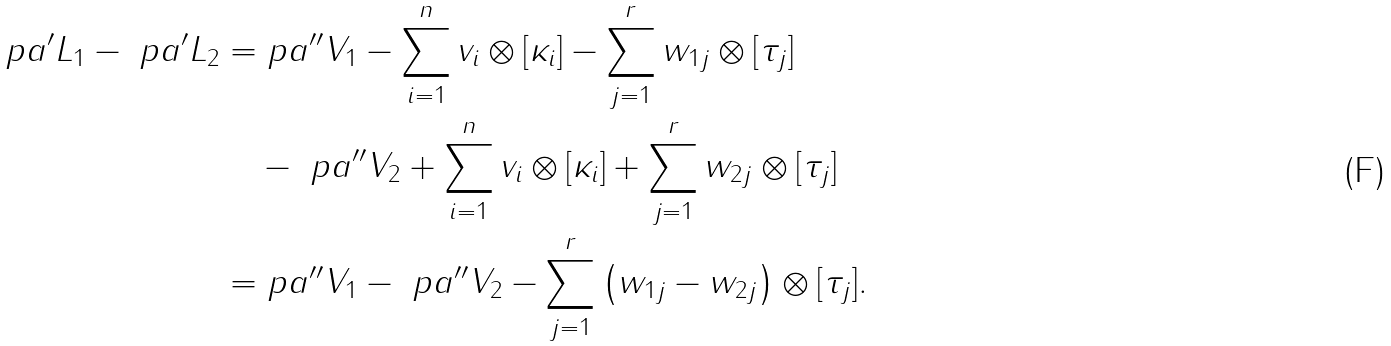<formula> <loc_0><loc_0><loc_500><loc_500>\ p a ^ { \prime } L _ { 1 } - \ p a ^ { \prime } L _ { 2 } = & \ p a ^ { \prime \prime } V _ { 1 } - \sum _ { i = 1 } ^ { n } v _ { i } \otimes [ \kappa _ { i } ] - \sum _ { j = 1 } ^ { r } w _ { 1 j } \otimes [ \tau _ { j } ] \\ & - \ p a ^ { \prime \prime } V _ { 2 } + \sum _ { i = 1 } ^ { n } v _ { i } \otimes [ \kappa _ { i } ] + \sum _ { j = 1 } ^ { r } w _ { 2 j } \otimes [ \tau _ { j } ] \\ = & \ p a ^ { \prime \prime } V _ { 1 } - \ p a ^ { \prime \prime } V _ { 2 } - \sum _ { j = 1 } ^ { r } \left ( w _ { 1 j } - w _ { 2 j } \right ) \otimes [ \tau _ { j } ] .</formula> 